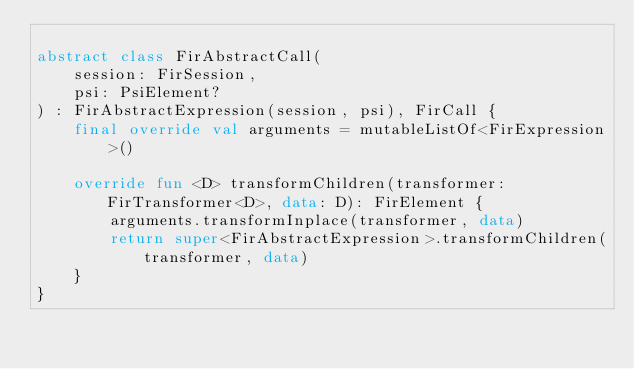<code> <loc_0><loc_0><loc_500><loc_500><_Kotlin_>
abstract class FirAbstractCall(
    session: FirSession,
    psi: PsiElement?
) : FirAbstractExpression(session, psi), FirCall {
    final override val arguments = mutableListOf<FirExpression>()

    override fun <D> transformChildren(transformer: FirTransformer<D>, data: D): FirElement {
        arguments.transformInplace(transformer, data)
        return super<FirAbstractExpression>.transformChildren(transformer, data)
    }
}</code> 